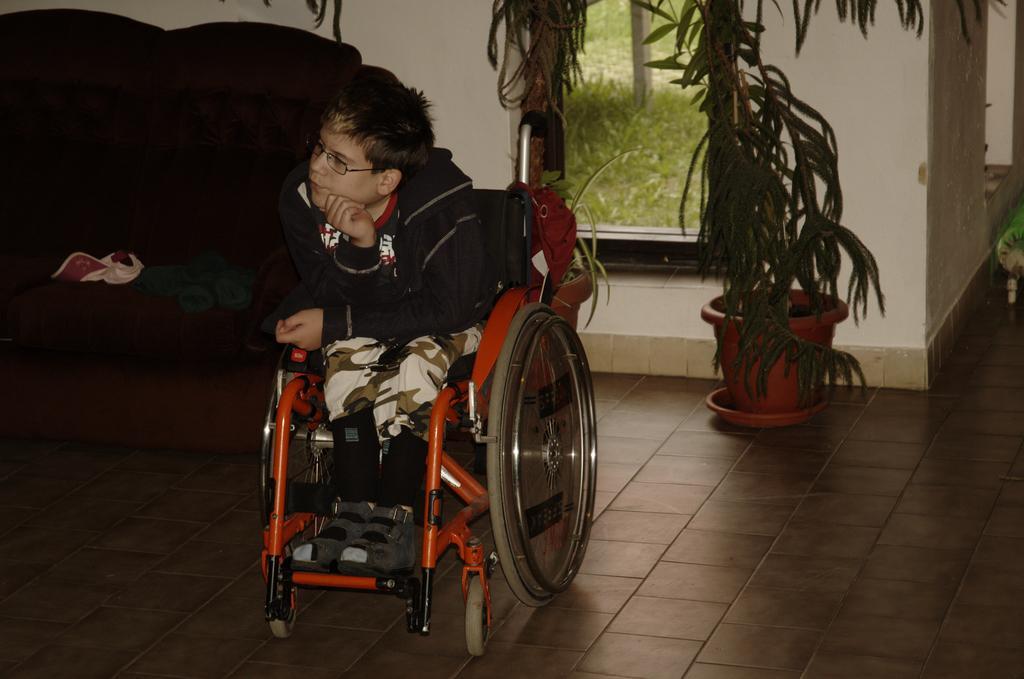Could you give a brief overview of what you see in this image? In the center of the image there is a boy sitting on a wheelchair. In the background of the image there is wall. There is a sofa. There is a flower pot with plant in it. There is a glass window through which we can see grass and pole. At the bottom of the image there is floor. 